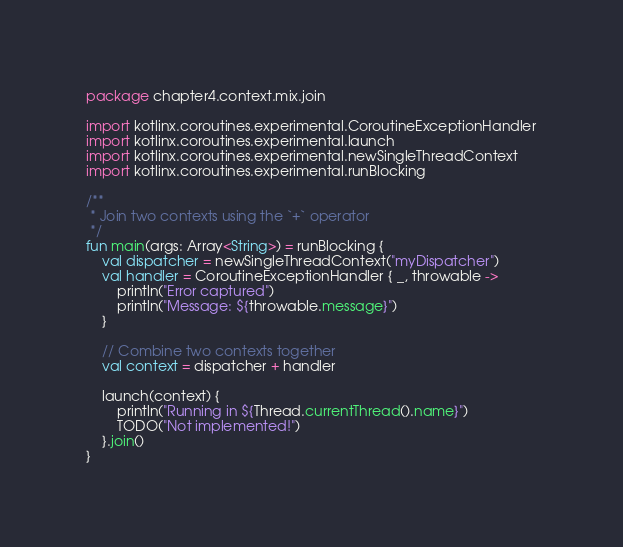Convert code to text. <code><loc_0><loc_0><loc_500><loc_500><_Kotlin_>package chapter4.context.mix.join

import kotlinx.coroutines.experimental.CoroutineExceptionHandler
import kotlinx.coroutines.experimental.launch
import kotlinx.coroutines.experimental.newSingleThreadContext
import kotlinx.coroutines.experimental.runBlocking

/**
 * Join two contexts using the `+` operator
 */
fun main(args: Array<String>) = runBlocking {
    val dispatcher = newSingleThreadContext("myDispatcher")
    val handler = CoroutineExceptionHandler { _, throwable ->
        println("Error captured")
        println("Message: ${throwable.message}")
    }

    // Combine two contexts together
    val context = dispatcher + handler

    launch(context) {
        println("Running in ${Thread.currentThread().name}")
        TODO("Not implemented!")
    }.join()
}</code> 